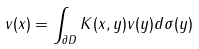Convert formula to latex. <formula><loc_0><loc_0><loc_500><loc_500>v ( x ) = \int _ { \partial D } K ( x , y ) v ( y ) d \sigma ( y )</formula> 